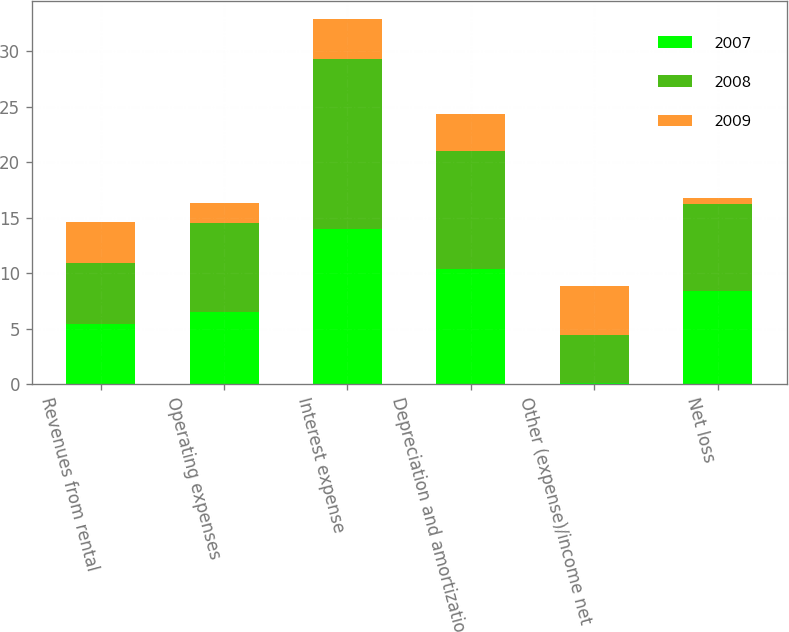Convert chart to OTSL. <chart><loc_0><loc_0><loc_500><loc_500><stacked_bar_chart><ecel><fcel>Revenues from rental<fcel>Operating expenses<fcel>Interest expense<fcel>Depreciation and amortization<fcel>Other (expense)/income net<fcel>Net loss<nl><fcel>2007<fcel>5.45<fcel>6.5<fcel>14<fcel>10.4<fcel>0.1<fcel>8.4<nl><fcel>2008<fcel>5.45<fcel>8<fcel>15.3<fcel>10.6<fcel>4.3<fcel>7.8<nl><fcel>2009<fcel>3.7<fcel>1.8<fcel>3.6<fcel>3.3<fcel>4.4<fcel>0.6<nl></chart> 